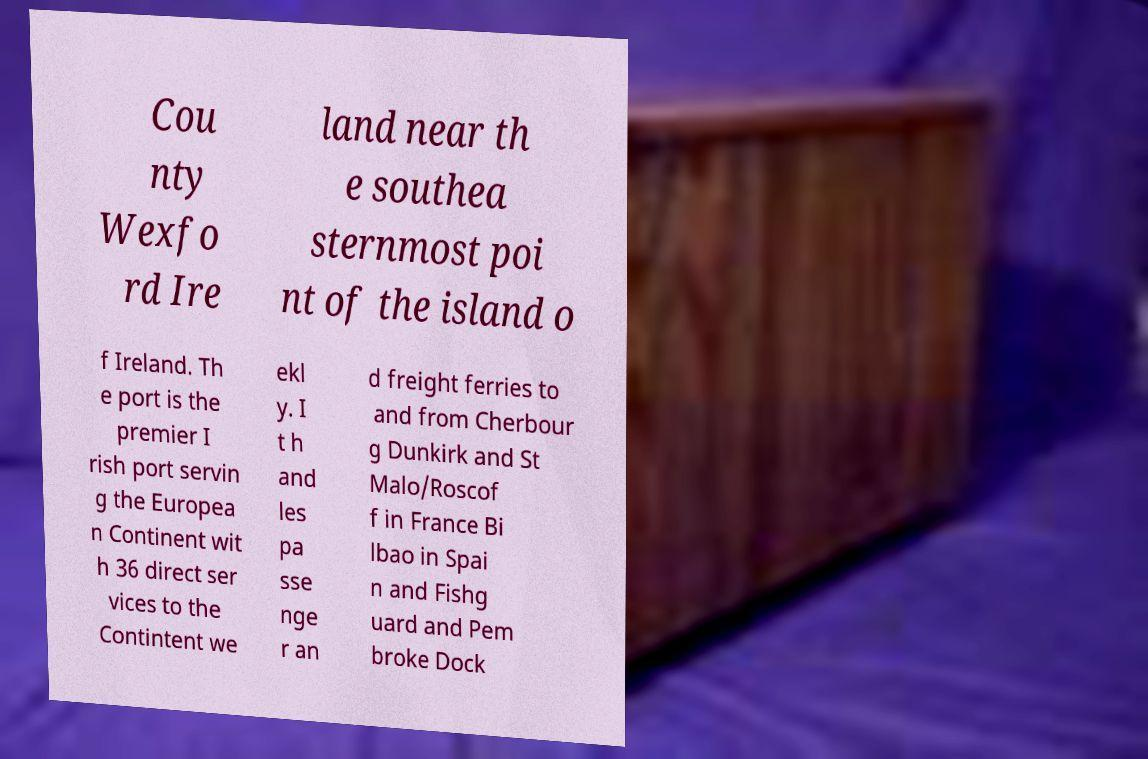For documentation purposes, I need the text within this image transcribed. Could you provide that? Cou nty Wexfo rd Ire land near th e southea sternmost poi nt of the island o f Ireland. Th e port is the premier I rish port servin g the Europea n Continent wit h 36 direct ser vices to the Contintent we ekl y. I t h and les pa sse nge r an d freight ferries to and from Cherbour g Dunkirk and St Malo/Roscof f in France Bi lbao in Spai n and Fishg uard and Pem broke Dock 